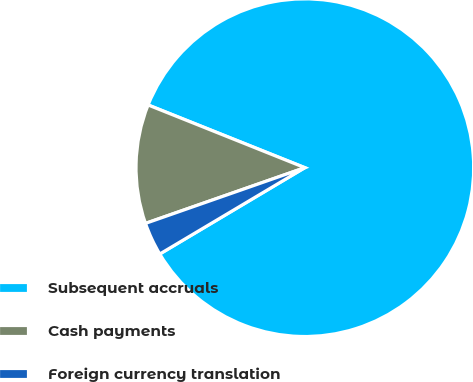Convert chart to OTSL. <chart><loc_0><loc_0><loc_500><loc_500><pie_chart><fcel>Subsequent accruals<fcel>Cash payments<fcel>Foreign currency translation<nl><fcel>85.4%<fcel>11.41%<fcel>3.19%<nl></chart> 